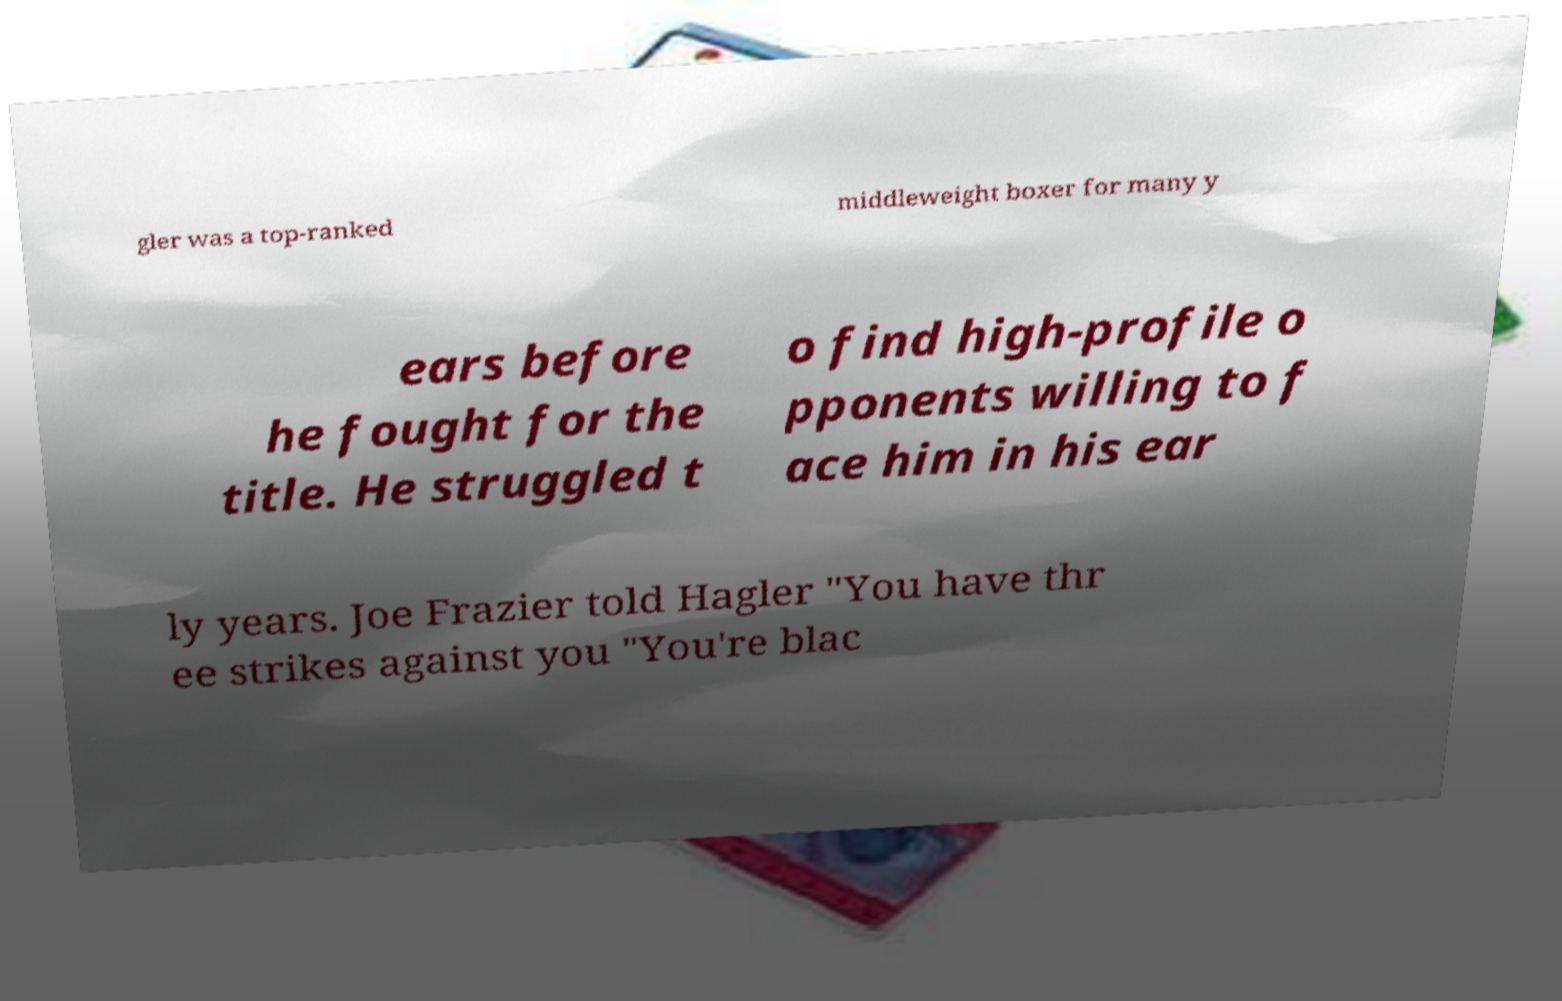There's text embedded in this image that I need extracted. Can you transcribe it verbatim? gler was a top-ranked middleweight boxer for many y ears before he fought for the title. He struggled t o find high-profile o pponents willing to f ace him in his ear ly years. Joe Frazier told Hagler "You have thr ee strikes against you "You're blac 